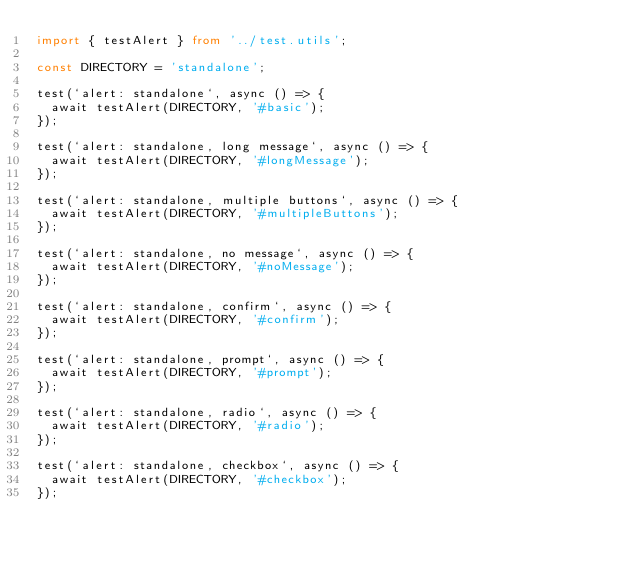<code> <loc_0><loc_0><loc_500><loc_500><_TypeScript_>import { testAlert } from '../test.utils';

const DIRECTORY = 'standalone';

test(`alert: standalone`, async () => {
  await testAlert(DIRECTORY, '#basic');
});

test(`alert: standalone, long message`, async () => {
  await testAlert(DIRECTORY, '#longMessage');
});

test(`alert: standalone, multiple buttons`, async () => {
  await testAlert(DIRECTORY, '#multipleButtons');
});

test(`alert: standalone, no message`, async () => {
  await testAlert(DIRECTORY, '#noMessage');
});

test(`alert: standalone, confirm`, async () => {
  await testAlert(DIRECTORY, '#confirm');
});

test(`alert: standalone, prompt`, async () => {
  await testAlert(DIRECTORY, '#prompt');
});

test(`alert: standalone, radio`, async () => {
  await testAlert(DIRECTORY, '#radio');
});

test(`alert: standalone, checkbox`, async () => {
  await testAlert(DIRECTORY, '#checkbox');
});
</code> 